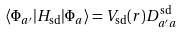Convert formula to latex. <formula><loc_0><loc_0><loc_500><loc_500>\langle \Phi _ { a ^ { \prime } } | H _ { \text {sd} } | \Phi _ { a } \rangle = V _ { \text {sd} } ( r ) D ^ { \text {sd} } _ { a ^ { \prime } a }</formula> 